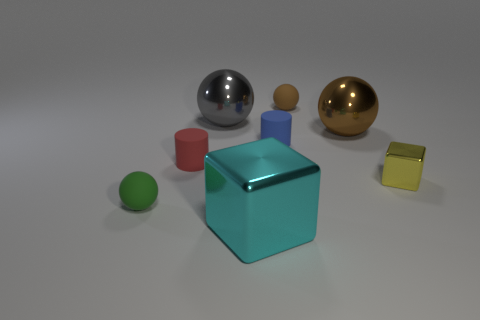What number of other objects are the same size as the cyan cube?
Your answer should be compact. 2. Do the tiny matte cylinder that is right of the big gray ball and the tiny metallic cube have the same color?
Your answer should be compact. No. Is the number of big brown things in front of the small green object greater than the number of big yellow metallic blocks?
Make the answer very short. No. Are there any other things of the same color as the small metal thing?
Offer a terse response. No. The small thing behind the big metal ball to the left of the tiny brown thing is what shape?
Make the answer very short. Sphere. Is the number of gray metallic spheres greater than the number of tiny gray metal objects?
Offer a very short reply. Yes. What number of large metallic objects are in front of the gray shiny sphere and to the left of the big brown shiny sphere?
Offer a terse response. 1. There is a cylinder to the left of the cyan cube; what number of big cyan cubes are to the left of it?
Offer a terse response. 0. How many objects are rubber balls right of the small green thing or objects that are behind the red cylinder?
Your answer should be compact. 4. What material is the other cyan thing that is the same shape as the small metal object?
Ensure brevity in your answer.  Metal. 